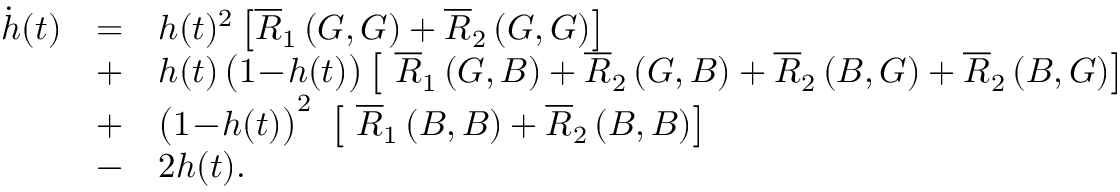<formula> <loc_0><loc_0><loc_500><loc_500>\begin{array} { l l l } { \dot { h } ( t ) } & { = } & { h ( t ) ^ { 2 } \left [ \overline { R } _ { 1 } \left ( G , G \right ) + \overline { R } _ { 2 } \left ( G , G \right ) \right ] } \\ & { + } & { h ( t ) \, \left ( 1 \, - \, h ( t ) \right ) \left [ \overline { R } _ { 1 } \left ( G , B \right ) + \overline { R } _ { 2 } \left ( G , B \right ) + \overline { R } _ { 2 } \left ( B , G \right ) + \overline { R } _ { 2 } \left ( B , G \right ) \right ] } \\ & { + } & { \left ( 1 \, - \, h ( t ) \right ) ^ { 2 } \left [ \overline { R } _ { 1 } \left ( B , B \right ) + \overline { R } _ { 2 } \left ( B , B \right ) \right ] } \\ & { - } & { 2 h ( t ) . } \end{array}</formula> 